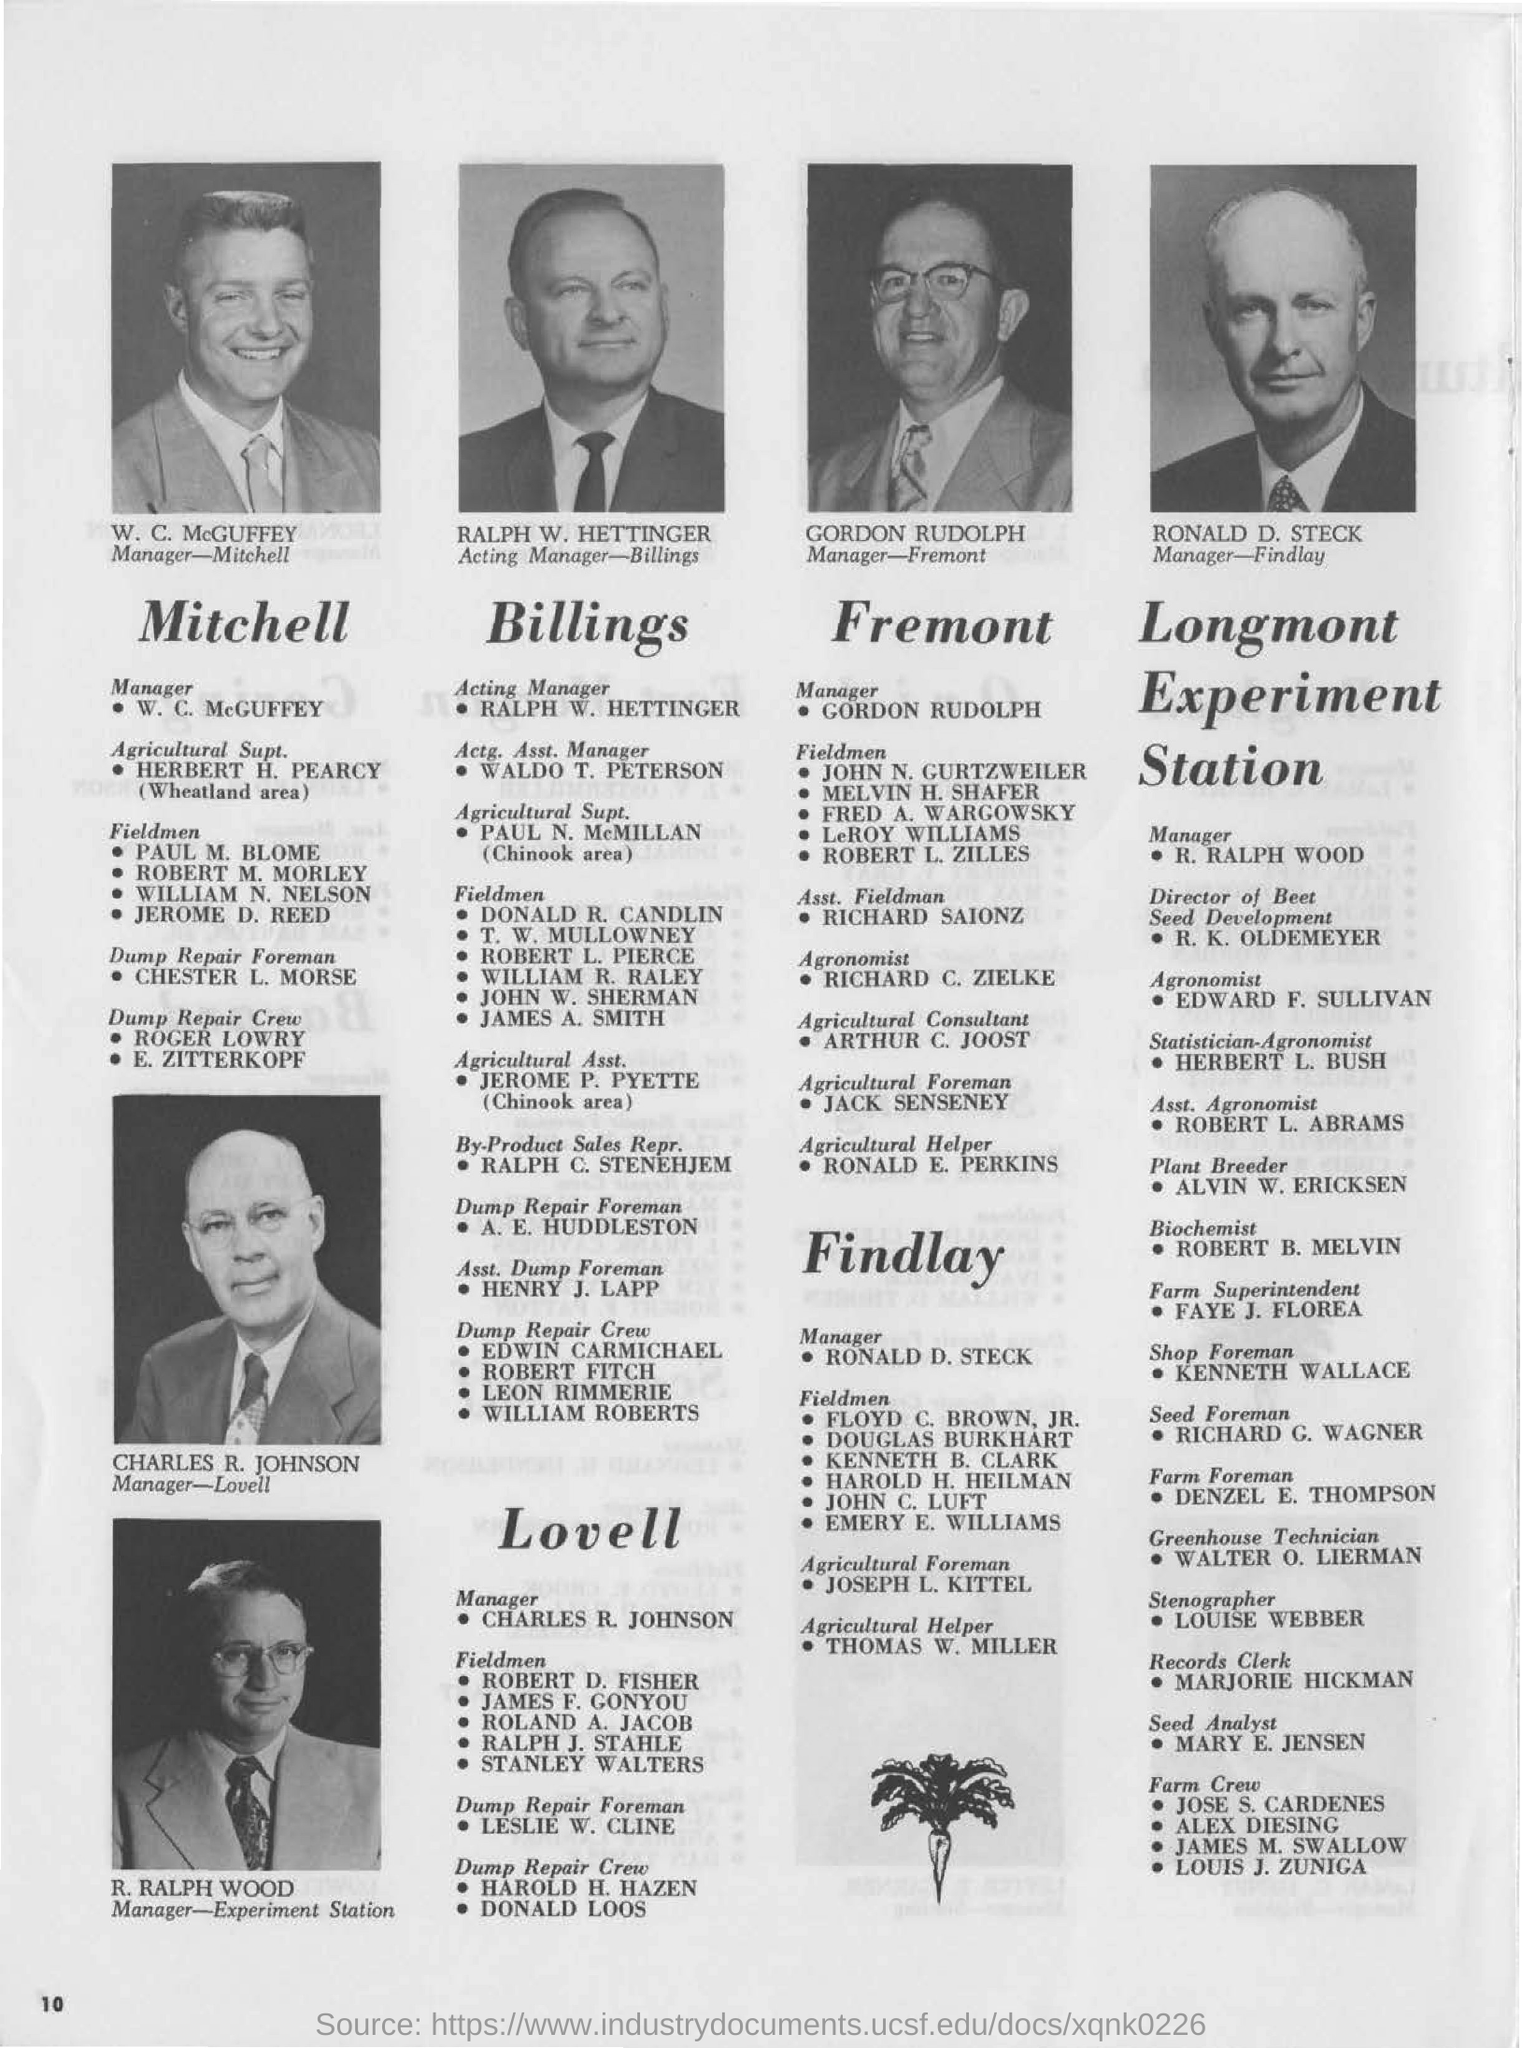Mention a couple of crucial points in this snapshot. The manager's name is Mitchell, and he is a manager named W. C. McGuffey. The agricultural foreman at Findlay is Joseph L. Kittel. Ralph W. Hettinger is the acting manager of Billings. 